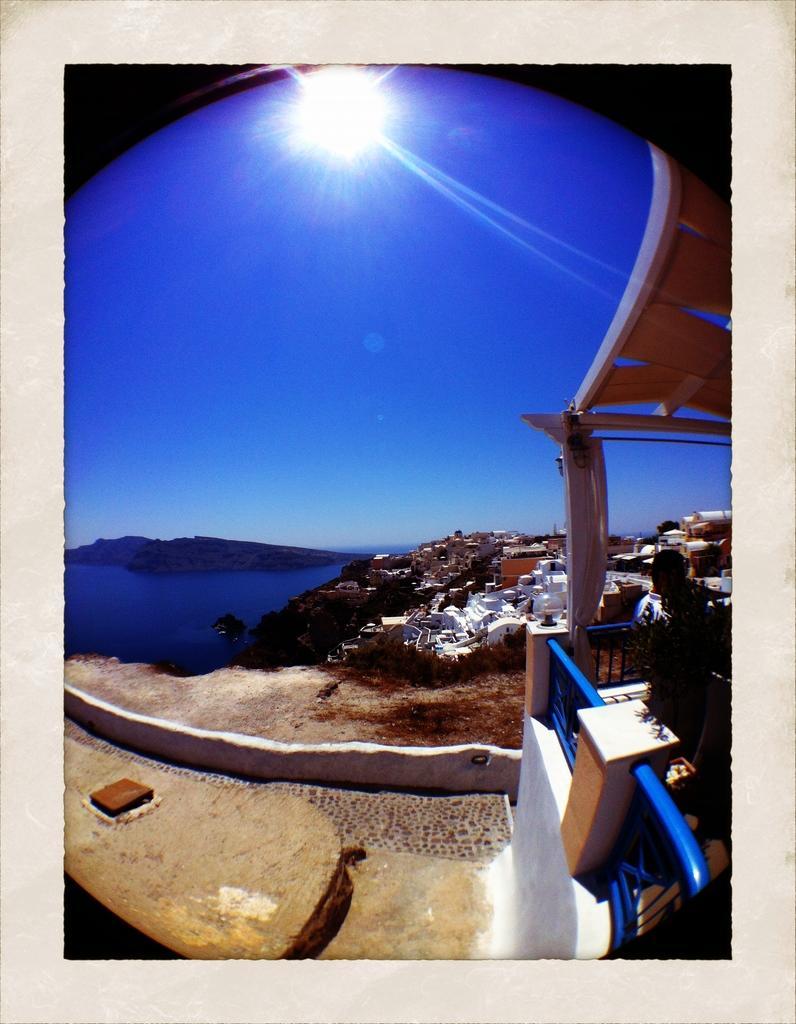How would you summarize this image in a sentence or two? In this image I can see number of buildings on the right side and on the left side I can see water. In the background I can see the sun and the sky. 